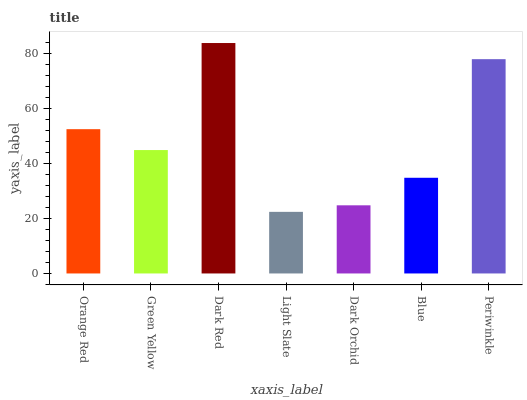Is Green Yellow the minimum?
Answer yes or no. No. Is Green Yellow the maximum?
Answer yes or no. No. Is Orange Red greater than Green Yellow?
Answer yes or no. Yes. Is Green Yellow less than Orange Red?
Answer yes or no. Yes. Is Green Yellow greater than Orange Red?
Answer yes or no. No. Is Orange Red less than Green Yellow?
Answer yes or no. No. Is Green Yellow the high median?
Answer yes or no. Yes. Is Green Yellow the low median?
Answer yes or no. Yes. Is Light Slate the high median?
Answer yes or no. No. Is Dark Orchid the low median?
Answer yes or no. No. 